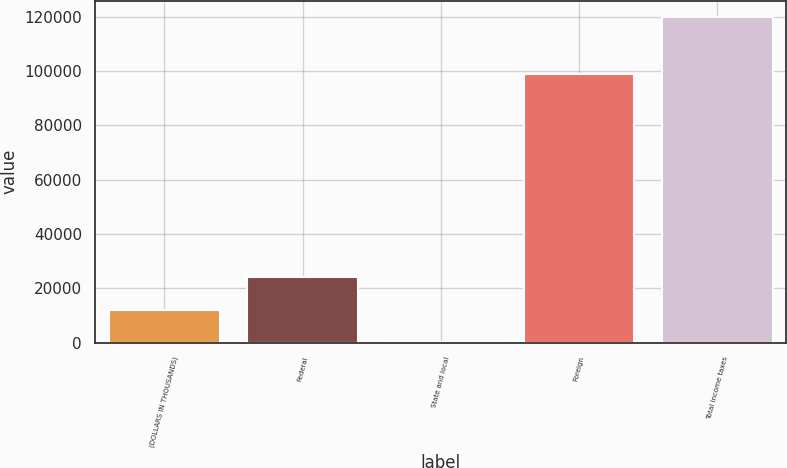Convert chart. <chart><loc_0><loc_0><loc_500><loc_500><bar_chart><fcel>(DOLLARS IN THOUSANDS)<fcel>Federal<fcel>State and local<fcel>Foreign<fcel>Total income taxes<nl><fcel>12164.5<fcel>24130<fcel>199<fcel>98964<fcel>119854<nl></chart> 